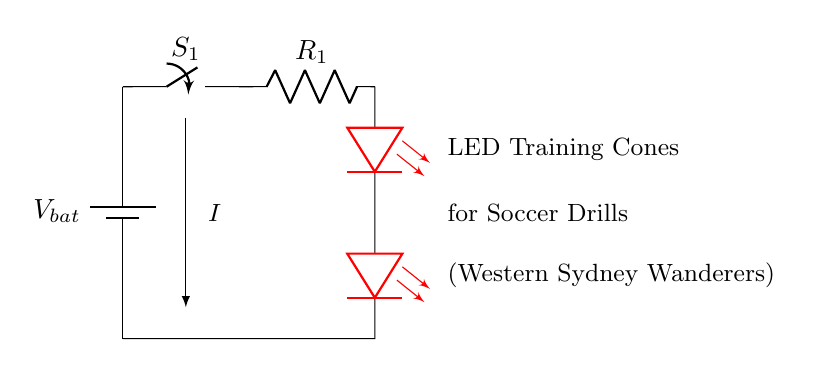What is the type of battery used in the circuit? The circuit diagram indicates a generic battery symbol, labeled as V bat. This implies that it is a direct current (DC) source, commonly used for powering DC devices like LEDs.
Answer: V bat How many LEDs are present in the circuit? By examining the circuit, we see two LED symbols in series connected to the battery and resistor. Since both are clearly marked as LEDs, we count them.
Answer: 2 What is the purpose of the resistor in the circuit? The resistor is indicated in the circuit and is typically used to limit the current flowing through the LEDs. This is crucial as excessive current may damage the LEDs.
Answer: Limit current What is the role of the switch in this circuit? The switch is positioned in series with the circuit. When it is closed, the circuit completes, allowing current to flow and turn on the LEDs. Conversely, when it is open, the circuit is broken, and the LEDs turn off.
Answer: Control flow What does the arrow in the circuit indicate? The arrow, labeled as I, represents the direction of current flow within the circuit. It demonstrates how the electrical current moves from the battery through the resistor to the LEDs and back to the battery.
Answer: Current direction What color are the LEDs in the circuit? The LEDs are specifically marked in the circuit as red. This information is clear from the component designation in the diagram, which shows the color associated with the LED symbols.
Answer: Red 